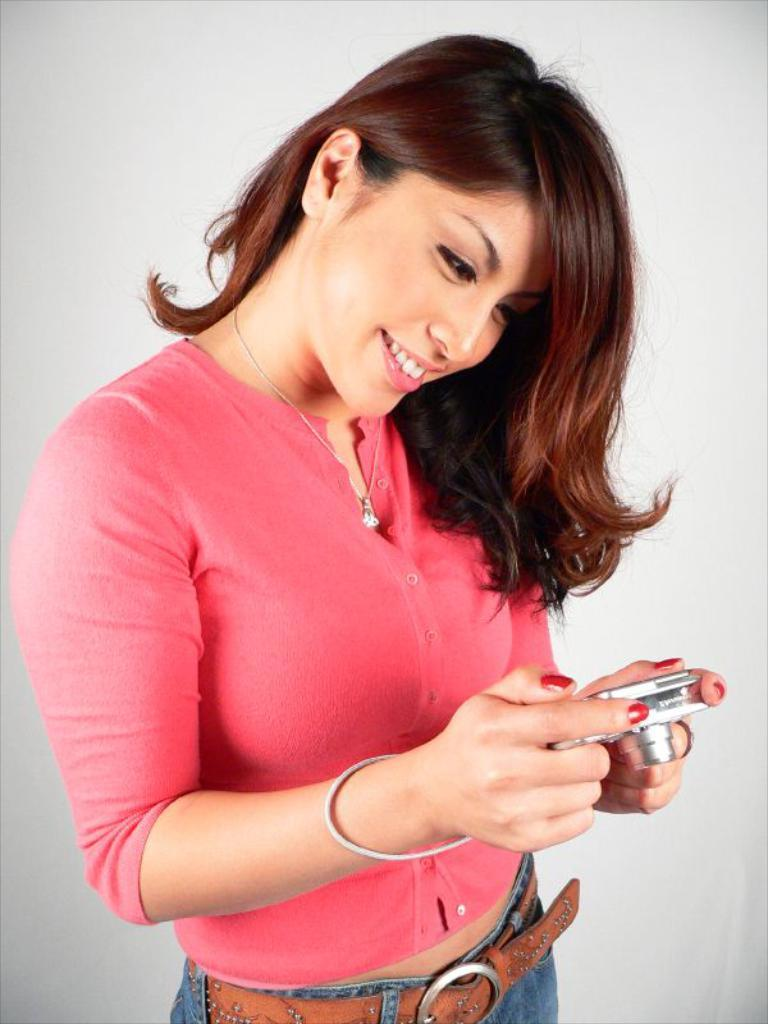Who is the main subject in the image? There is a lady in the center of the image. What is the lady holding in the image? The lady is holding a camera. What can be seen in the background of the image? There is a wall in the background of the image. Where is the nest located in the image? There is no nest present in the image. How does the lady's breath affect the camera in the image? The lady's breath does not affect the camera in the image, as there is no indication of her breathing on the camera. 